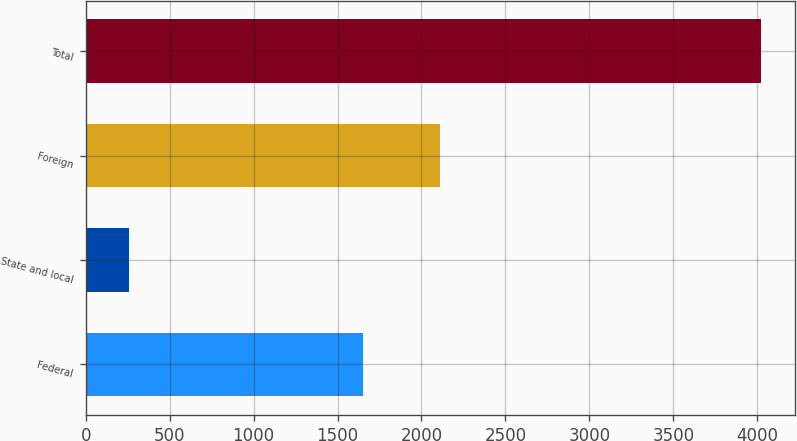Convert chart. <chart><loc_0><loc_0><loc_500><loc_500><bar_chart><fcel>Federal<fcel>State and local<fcel>Foreign<fcel>Total<nl><fcel>1651<fcel>260<fcel>2111<fcel>4022<nl></chart> 